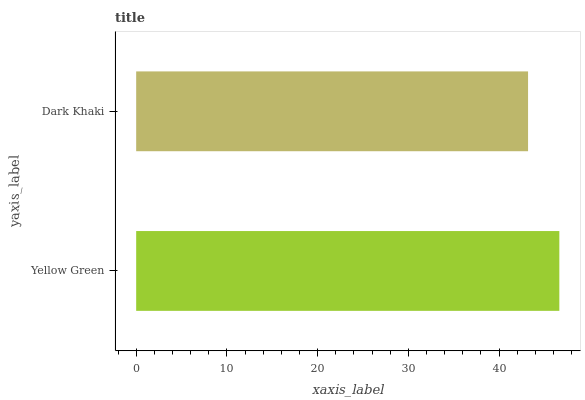Is Dark Khaki the minimum?
Answer yes or no. Yes. Is Yellow Green the maximum?
Answer yes or no. Yes. Is Dark Khaki the maximum?
Answer yes or no. No. Is Yellow Green greater than Dark Khaki?
Answer yes or no. Yes. Is Dark Khaki less than Yellow Green?
Answer yes or no. Yes. Is Dark Khaki greater than Yellow Green?
Answer yes or no. No. Is Yellow Green less than Dark Khaki?
Answer yes or no. No. Is Yellow Green the high median?
Answer yes or no. Yes. Is Dark Khaki the low median?
Answer yes or no. Yes. Is Dark Khaki the high median?
Answer yes or no. No. Is Yellow Green the low median?
Answer yes or no. No. 